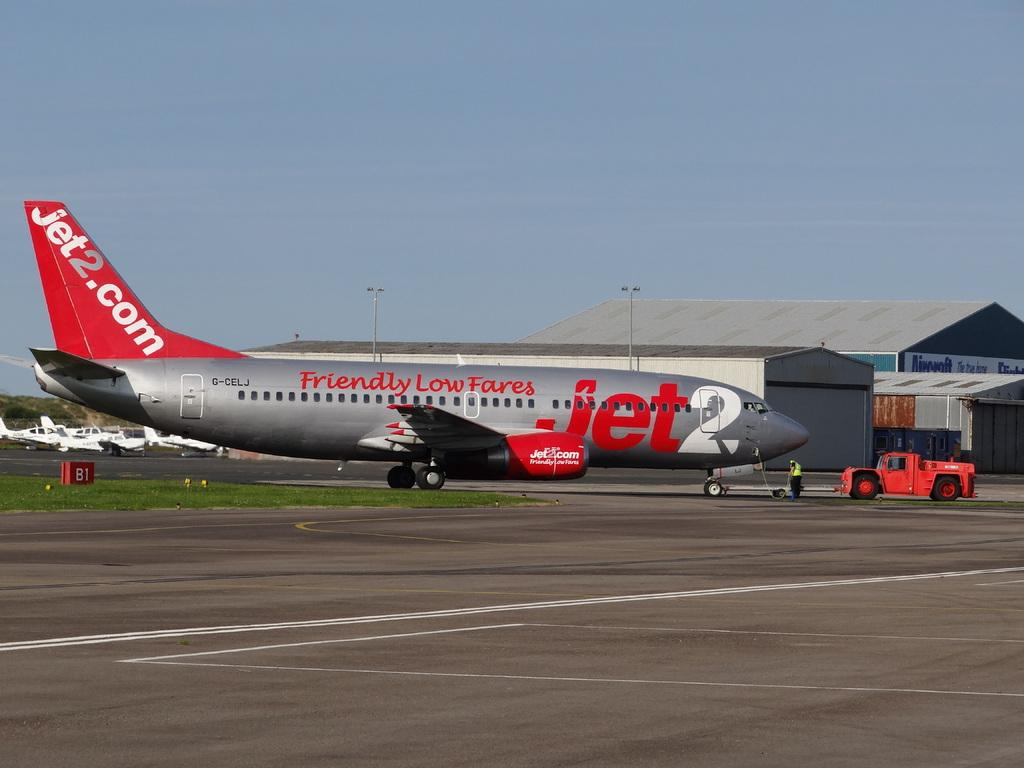<image>
Create a compact narrative representing the image presented. a plane sitting on a runway with Friendly Low Fares on the side 